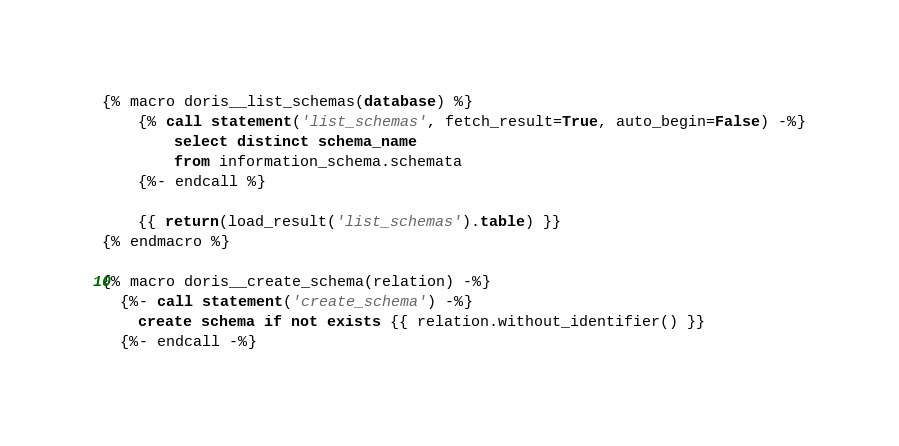<code> <loc_0><loc_0><loc_500><loc_500><_SQL_>
{% macro doris__list_schemas(database) %}
    {% call statement('list_schemas', fetch_result=True, auto_begin=False) -%}
        select distinct schema_name
        from information_schema.schemata
    {%- endcall %}

    {{ return(load_result('list_schemas').table) }}
{% endmacro %}

{% macro doris__create_schema(relation) -%}
  {%- call statement('create_schema') -%}
    create schema if not exists {{ relation.without_identifier() }}
  {%- endcall -%}</code> 